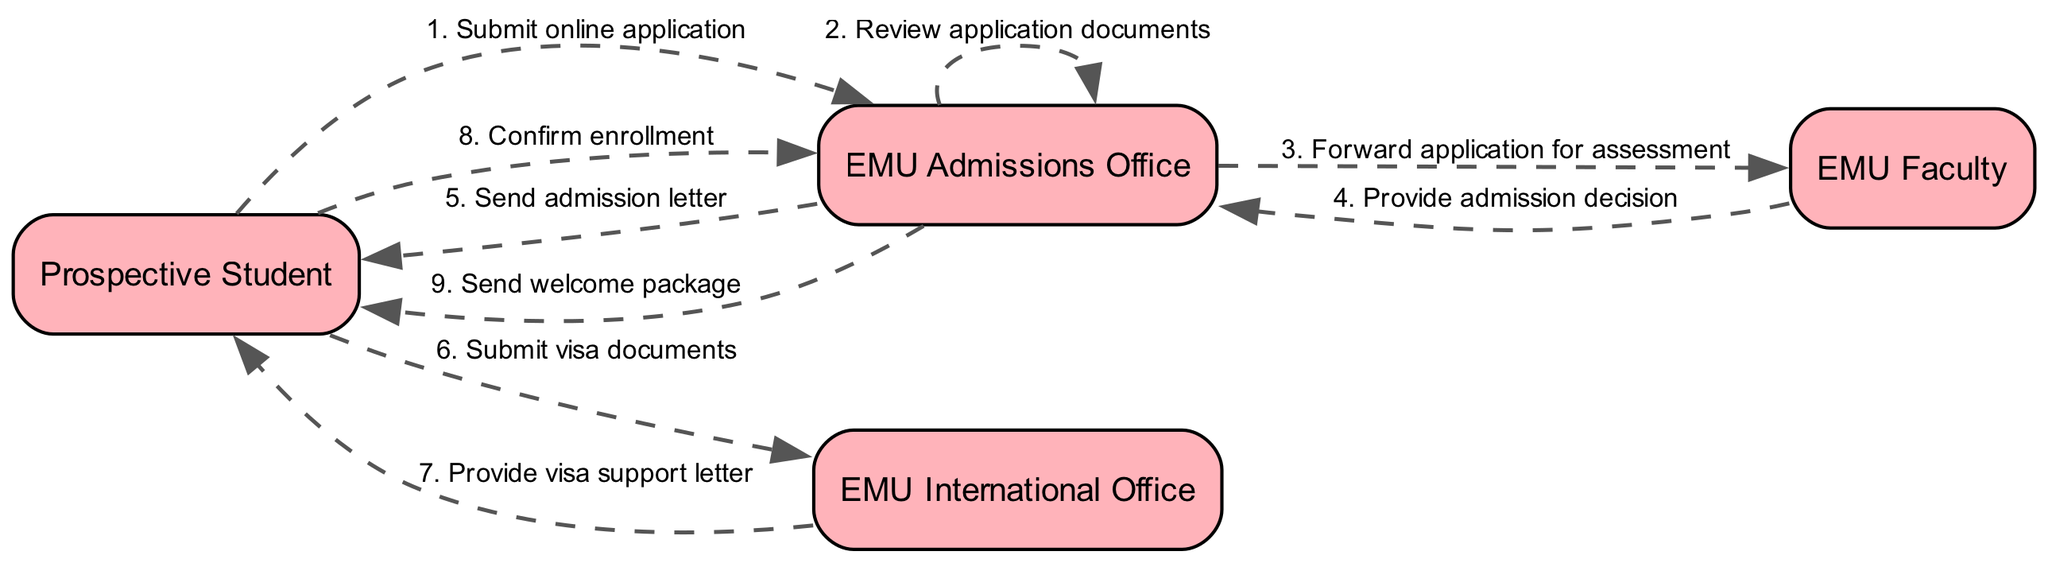What is the first action taken by the prospective student? The first action in the sequence diagram shows the prospective student submitting an online application to the EMU Admissions Office.
Answer: Submit online application How many actors are involved in the admission process? There are four actors in the diagram: Prospective Student, EMU Admissions Office, EMU International Office, and EMU Faculty.
Answer: Four Who sends the visa support letter? The EMU International Office is responsible for providing and sending the visa support letter to the prospective student.
Answer: EMU International Office What action follows the admission letter sent to the prospective student? After sending the admission letter, the next action in the sequence is for the prospective student to submit visa documents to the EMU International Office.
Answer: Submit visa documents Which actor confirms the enrollment? The prospective student is the actor that confirms their enrollment after receiving the admission letter.
Answer: Prospective Student What is the last action in the sequence? The final action in the sequence is the EMU Admissions Office sending a welcome package to the prospective student.
Answer: Send welcome package How many actions occur before enrollment confirmation? There are six actions that occur before the confirmation of enrollment by the prospective student.
Answer: Six Which document is submitted to the EMU International Office? The prospective student submits visa documents to the EMU International Office.
Answer: Visa documents What role does the EMU Faculty play in the admission process? The EMU Faculty's role is to assess the application and provide the admission decision back to the EMU Admissions Office.
Answer: Provide admission decision 